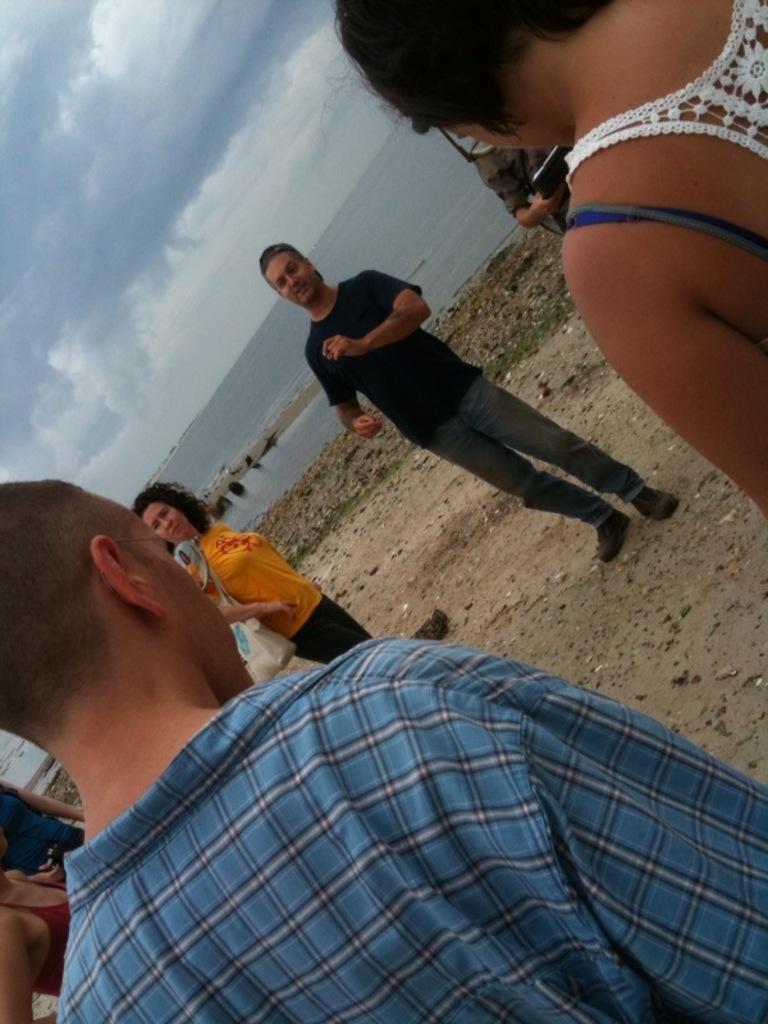Please provide a concise description of this image. In this image we can see there are a few people standing. In the background there is a river and a sky. 